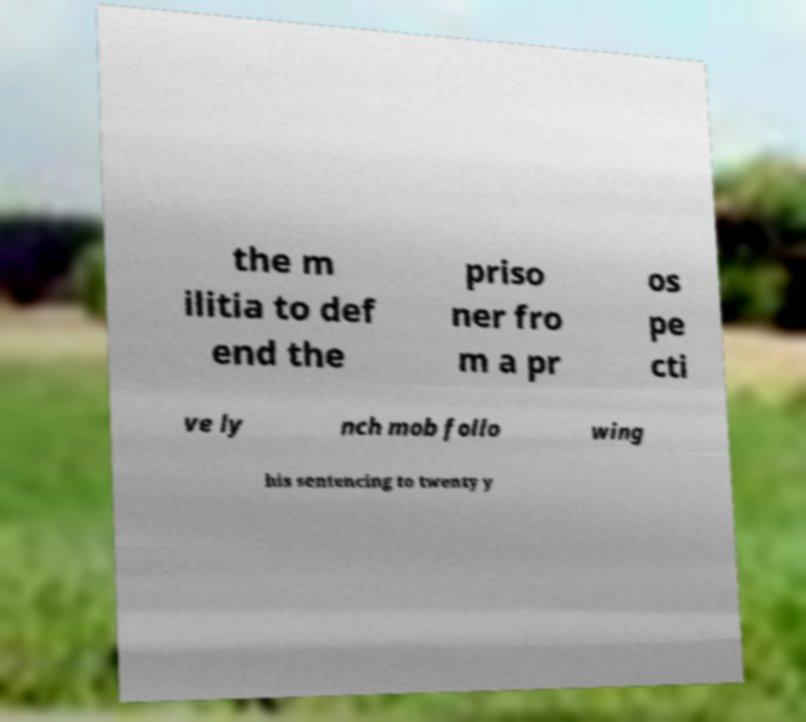Please read and relay the text visible in this image. What does it say? the m ilitia to def end the priso ner fro m a pr os pe cti ve ly nch mob follo wing his sentencing to twenty y 